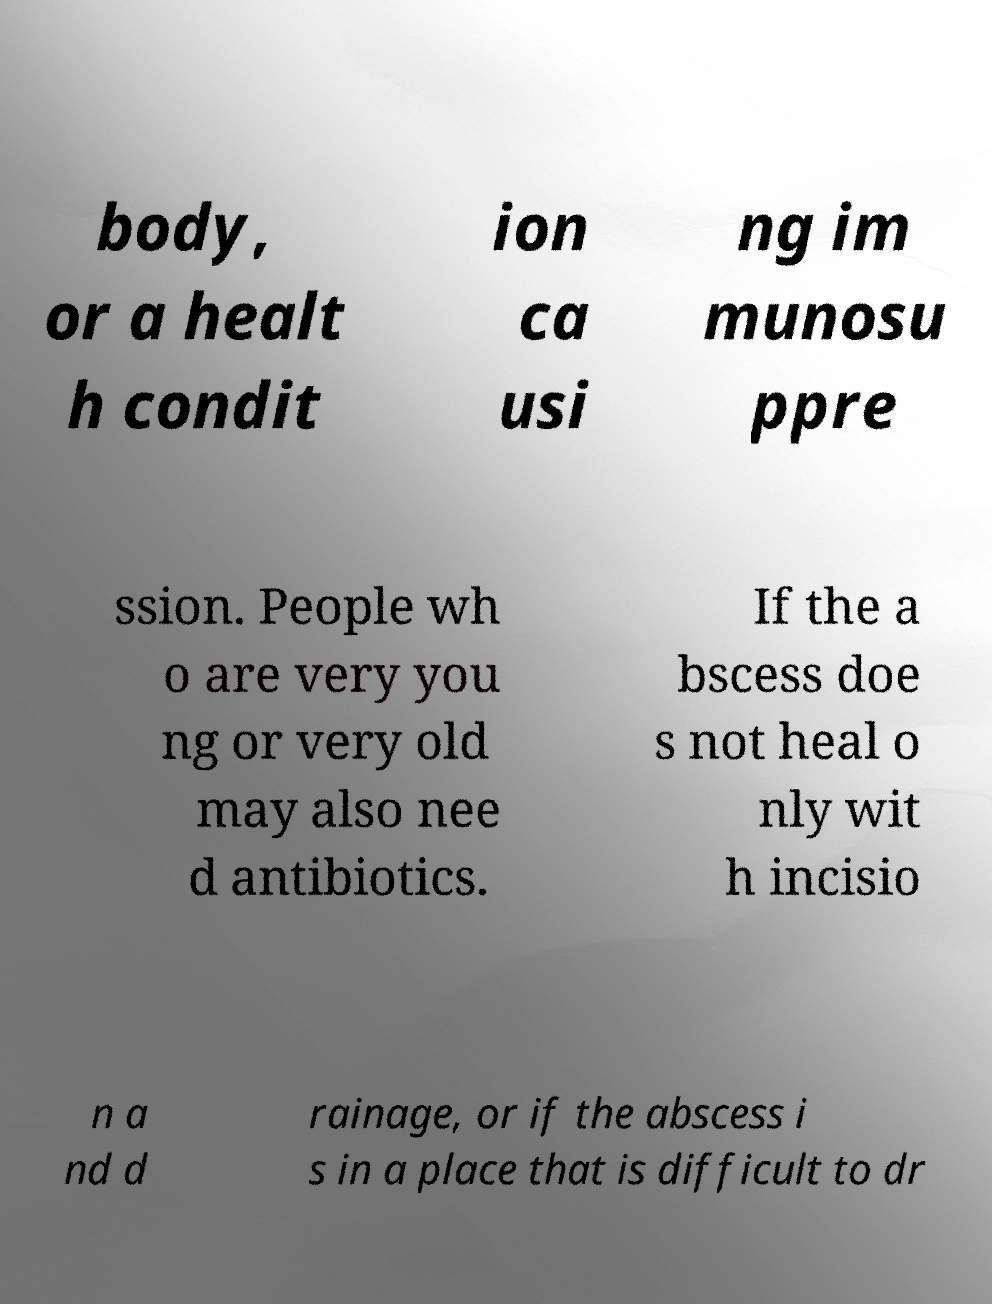Can you read and provide the text displayed in the image?This photo seems to have some interesting text. Can you extract and type it out for me? body, or a healt h condit ion ca usi ng im munosu ppre ssion. People wh o are very you ng or very old may also nee d antibiotics. If the a bscess doe s not heal o nly wit h incisio n a nd d rainage, or if the abscess i s in a place that is difficult to dr 